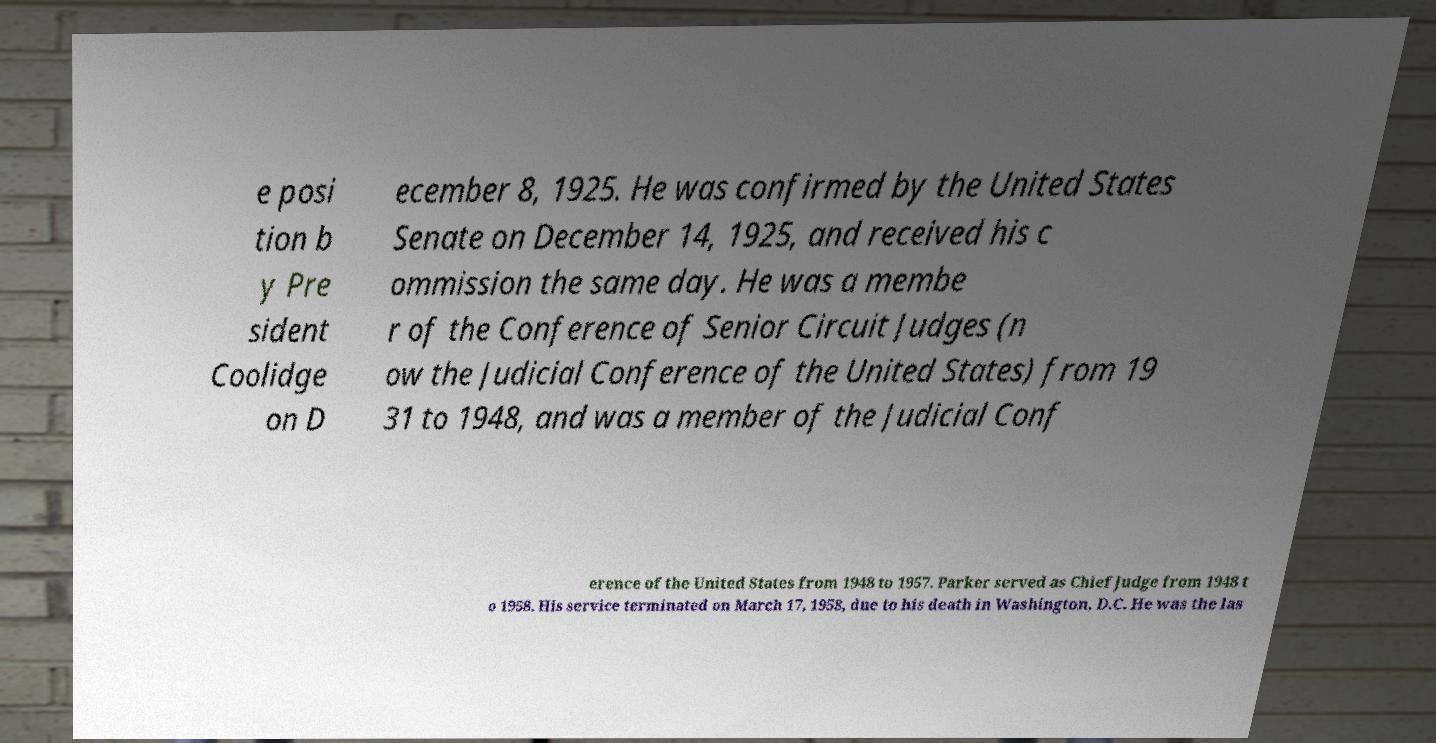Can you read and provide the text displayed in the image?This photo seems to have some interesting text. Can you extract and type it out for me? e posi tion b y Pre sident Coolidge on D ecember 8, 1925. He was confirmed by the United States Senate on December 14, 1925, and received his c ommission the same day. He was a membe r of the Conference of Senior Circuit Judges (n ow the Judicial Conference of the United States) from 19 31 to 1948, and was a member of the Judicial Conf erence of the United States from 1948 to 1957. Parker served as Chief Judge from 1948 t o 1958. His service terminated on March 17, 1958, due to his death in Washington, D.C. He was the las 